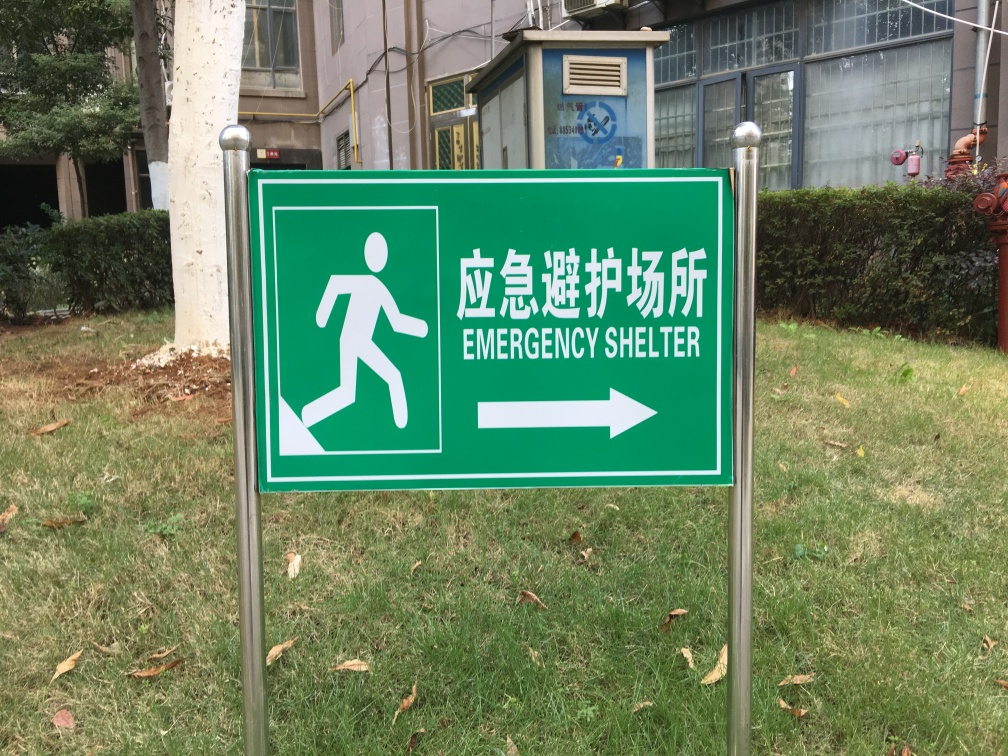Are there any quality issues with this image? Yes, there are a few quality issues with the image: it's slightly tilted to the right, which affects its balance, and there's a minor lack of sharpness which may reduce the clarity of the details. Additionally, the lighting is flat, lacking depth and contrast. 